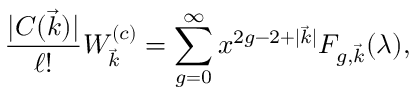Convert formula to latex. <formula><loc_0><loc_0><loc_500><loc_500>{ \frac { | C ( \vec { k } ) | } { \ell ! } } W _ { \vec { k } } ^ { ( c ) } = \sum _ { g = 0 } ^ { \infty } x ^ { 2 g - 2 + | \vec { k } | } F _ { g , \vec { k } } ( \lambda ) ,</formula> 